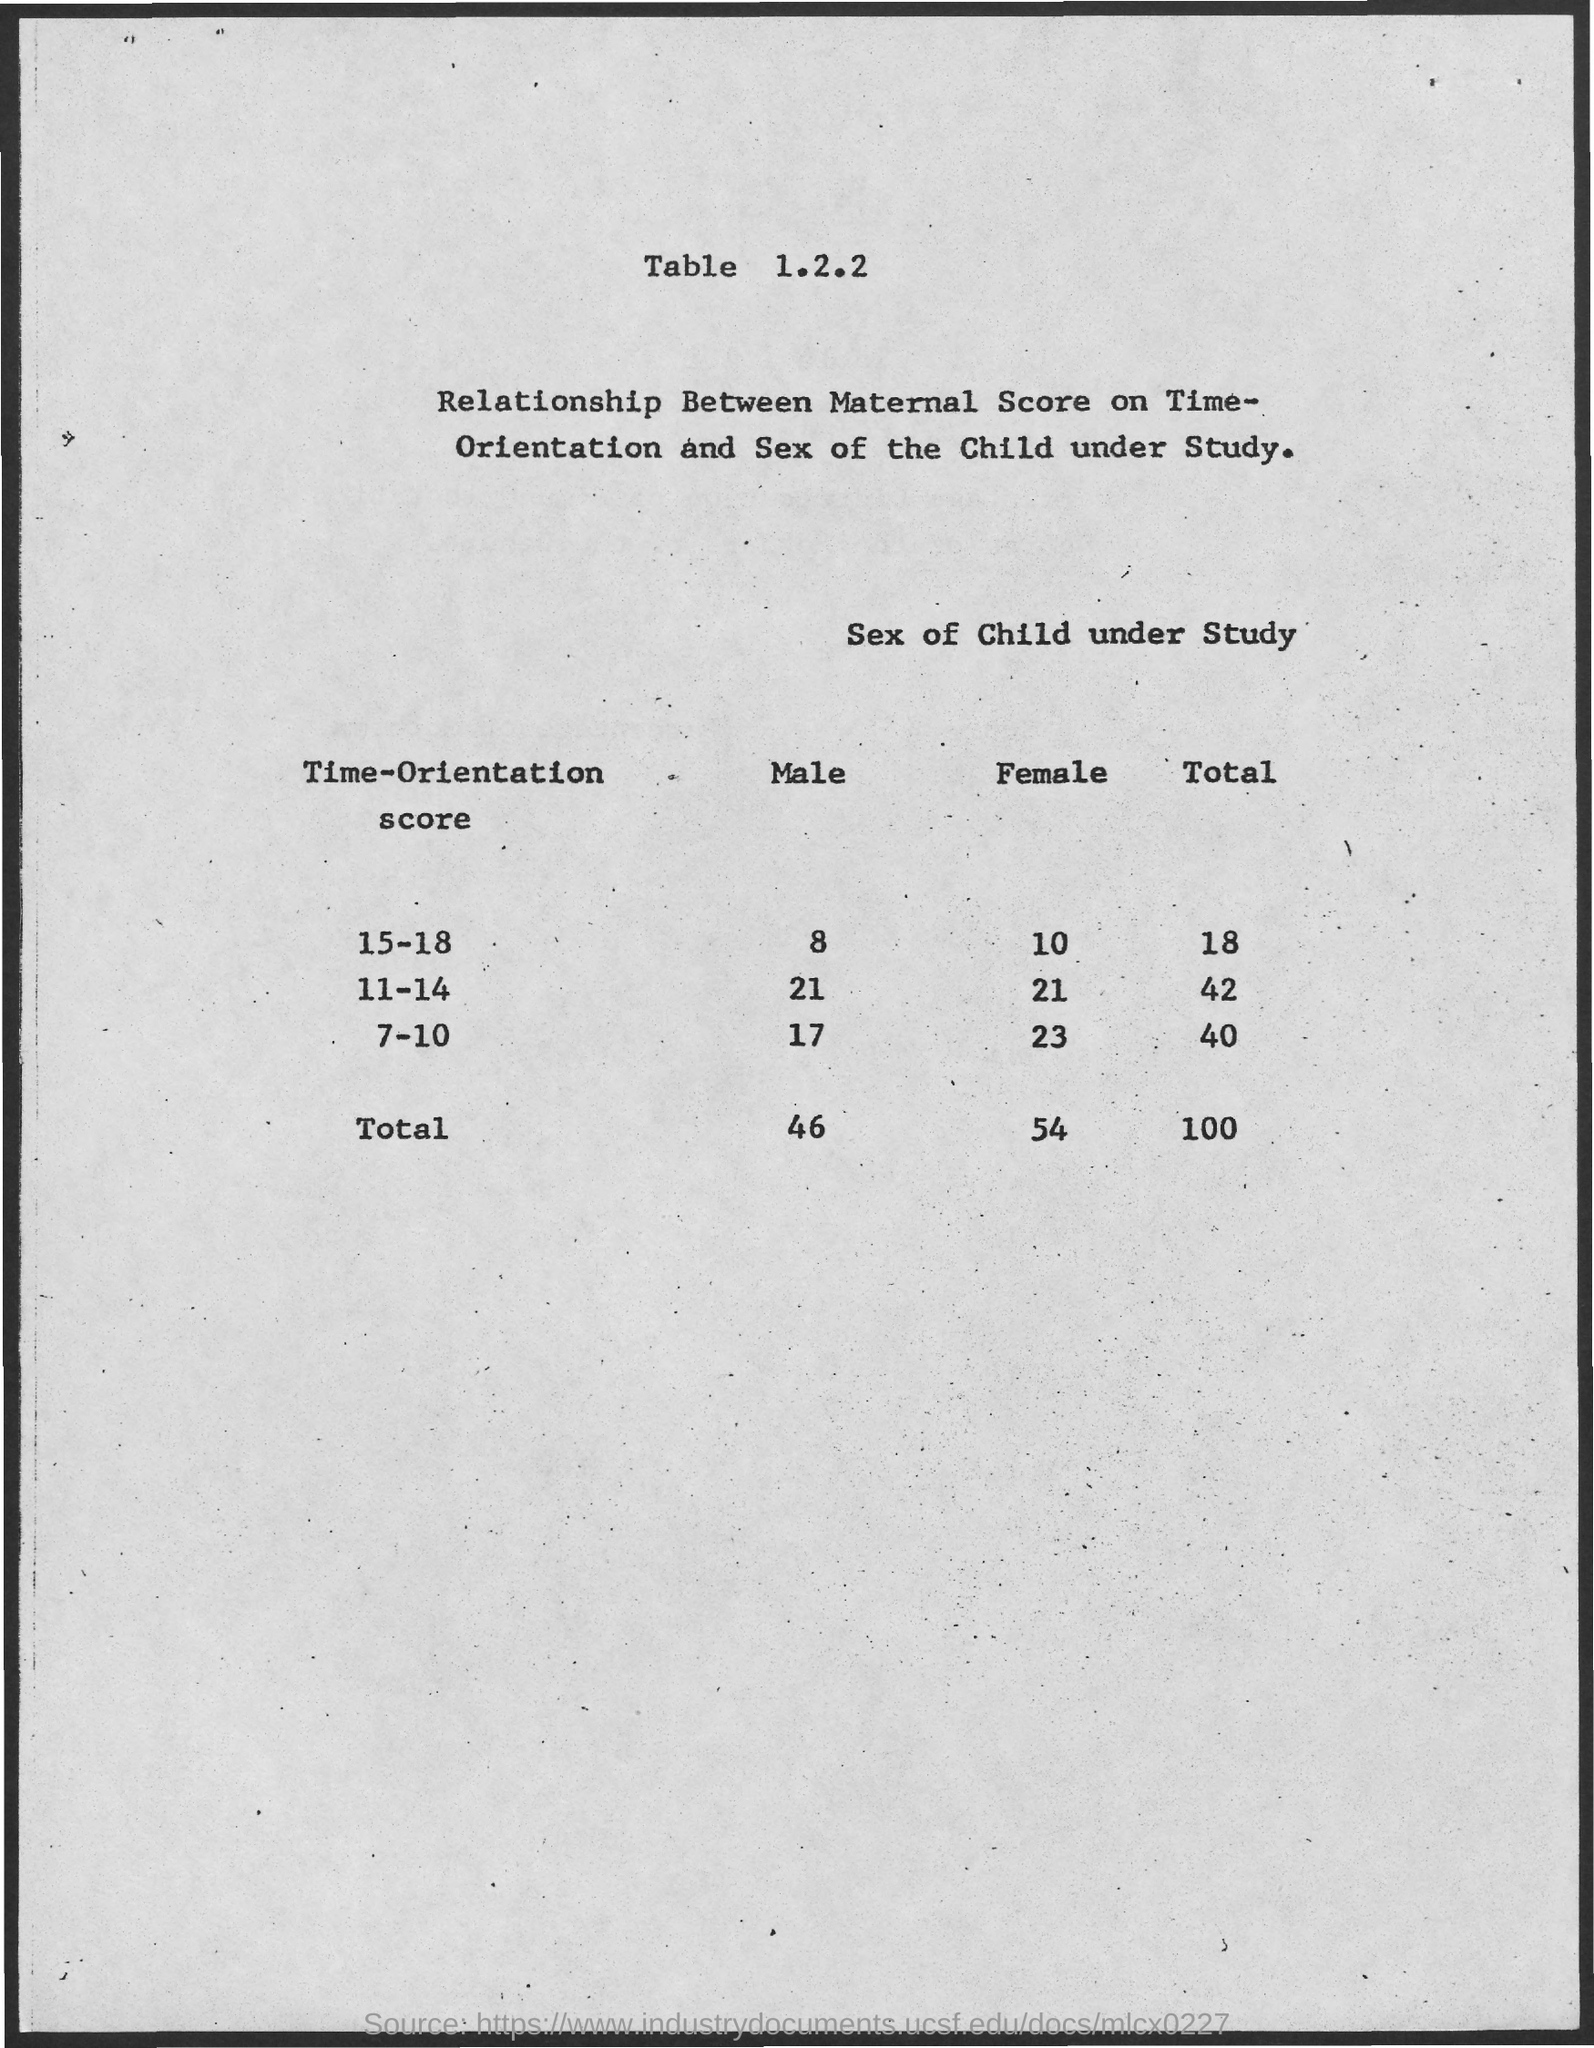Outline some significant characteristics in this image. The table number is 1.2.2. The number of males with a time-orientation score of 15-18 is 8. There are 23 females with a time-orientation score of 7 to 10. 